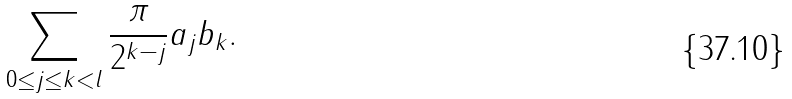<formula> <loc_0><loc_0><loc_500><loc_500>\sum _ { 0 \leq j \leq k < l } \frac { \pi } { 2 ^ { k - j } } a _ { j } b _ { k } .</formula> 